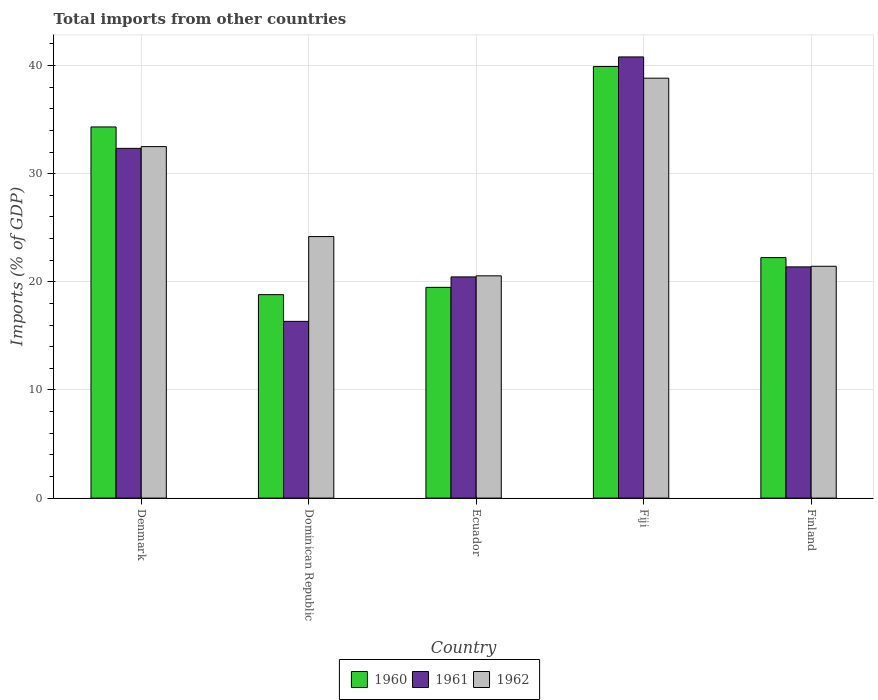How many groups of bars are there?
Your answer should be compact. 5. Are the number of bars per tick equal to the number of legend labels?
Your answer should be very brief. Yes. What is the label of the 2nd group of bars from the left?
Give a very brief answer. Dominican Republic. In how many cases, is the number of bars for a given country not equal to the number of legend labels?
Provide a short and direct response. 0. What is the total imports in 1961 in Denmark?
Provide a short and direct response. 32.34. Across all countries, what is the maximum total imports in 1960?
Your response must be concise. 39.91. Across all countries, what is the minimum total imports in 1960?
Offer a very short reply. 18.81. In which country was the total imports in 1962 maximum?
Your response must be concise. Fiji. In which country was the total imports in 1962 minimum?
Your response must be concise. Ecuador. What is the total total imports in 1962 in the graph?
Offer a terse response. 137.51. What is the difference between the total imports in 1962 in Fiji and that in Finland?
Your answer should be compact. 17.39. What is the difference between the total imports in 1961 in Finland and the total imports in 1960 in Fiji?
Offer a very short reply. -18.53. What is the average total imports in 1961 per country?
Provide a succinct answer. 26.26. What is the difference between the total imports of/in 1962 and total imports of/in 1961 in Dominican Republic?
Offer a very short reply. 7.84. What is the ratio of the total imports in 1961 in Dominican Republic to that in Fiji?
Provide a short and direct response. 0.4. Is the total imports in 1960 in Denmark less than that in Fiji?
Provide a short and direct response. Yes. Is the difference between the total imports in 1962 in Denmark and Ecuador greater than the difference between the total imports in 1961 in Denmark and Ecuador?
Offer a terse response. Yes. What is the difference between the highest and the second highest total imports in 1960?
Keep it short and to the point. 12.08. What is the difference between the highest and the lowest total imports in 1960?
Offer a very short reply. 21.1. Is the sum of the total imports in 1962 in Ecuador and Fiji greater than the maximum total imports in 1961 across all countries?
Make the answer very short. Yes. What does the 1st bar from the left in Finland represents?
Keep it short and to the point. 1960. What does the 3rd bar from the right in Denmark represents?
Provide a succinct answer. 1960. Is it the case that in every country, the sum of the total imports in 1961 and total imports in 1962 is greater than the total imports in 1960?
Give a very brief answer. Yes. How many bars are there?
Your answer should be compact. 15. What is the difference between two consecutive major ticks on the Y-axis?
Ensure brevity in your answer.  10. Does the graph contain any zero values?
Make the answer very short. No. Where does the legend appear in the graph?
Keep it short and to the point. Bottom center. What is the title of the graph?
Make the answer very short. Total imports from other countries. Does "1986" appear as one of the legend labels in the graph?
Provide a succinct answer. No. What is the label or title of the Y-axis?
Make the answer very short. Imports (% of GDP). What is the Imports (% of GDP) of 1960 in Denmark?
Your answer should be very brief. 34.32. What is the Imports (% of GDP) of 1961 in Denmark?
Ensure brevity in your answer.  32.34. What is the Imports (% of GDP) of 1962 in Denmark?
Your response must be concise. 32.5. What is the Imports (% of GDP) in 1960 in Dominican Republic?
Offer a terse response. 18.81. What is the Imports (% of GDP) in 1961 in Dominican Republic?
Ensure brevity in your answer.  16.34. What is the Imports (% of GDP) of 1962 in Dominican Republic?
Ensure brevity in your answer.  24.18. What is the Imports (% of GDP) of 1960 in Ecuador?
Offer a terse response. 19.49. What is the Imports (% of GDP) of 1961 in Ecuador?
Provide a succinct answer. 20.45. What is the Imports (% of GDP) of 1962 in Ecuador?
Offer a terse response. 20.55. What is the Imports (% of GDP) in 1960 in Fiji?
Keep it short and to the point. 39.91. What is the Imports (% of GDP) of 1961 in Fiji?
Make the answer very short. 40.8. What is the Imports (% of GDP) of 1962 in Fiji?
Provide a succinct answer. 38.83. What is the Imports (% of GDP) in 1960 in Finland?
Offer a terse response. 22.24. What is the Imports (% of GDP) of 1961 in Finland?
Provide a short and direct response. 21.38. What is the Imports (% of GDP) of 1962 in Finland?
Give a very brief answer. 21.44. Across all countries, what is the maximum Imports (% of GDP) of 1960?
Offer a terse response. 39.91. Across all countries, what is the maximum Imports (% of GDP) of 1961?
Your response must be concise. 40.8. Across all countries, what is the maximum Imports (% of GDP) in 1962?
Offer a terse response. 38.83. Across all countries, what is the minimum Imports (% of GDP) in 1960?
Keep it short and to the point. 18.81. Across all countries, what is the minimum Imports (% of GDP) of 1961?
Offer a terse response. 16.34. Across all countries, what is the minimum Imports (% of GDP) of 1962?
Offer a terse response. 20.55. What is the total Imports (% of GDP) of 1960 in the graph?
Offer a very short reply. 134.77. What is the total Imports (% of GDP) in 1961 in the graph?
Keep it short and to the point. 131.32. What is the total Imports (% of GDP) in 1962 in the graph?
Provide a short and direct response. 137.51. What is the difference between the Imports (% of GDP) in 1960 in Denmark and that in Dominican Republic?
Your response must be concise. 15.51. What is the difference between the Imports (% of GDP) of 1961 in Denmark and that in Dominican Republic?
Your answer should be compact. 16. What is the difference between the Imports (% of GDP) in 1962 in Denmark and that in Dominican Republic?
Offer a terse response. 8.32. What is the difference between the Imports (% of GDP) in 1960 in Denmark and that in Ecuador?
Keep it short and to the point. 14.83. What is the difference between the Imports (% of GDP) of 1961 in Denmark and that in Ecuador?
Give a very brief answer. 11.89. What is the difference between the Imports (% of GDP) of 1962 in Denmark and that in Ecuador?
Provide a succinct answer. 11.95. What is the difference between the Imports (% of GDP) in 1960 in Denmark and that in Fiji?
Keep it short and to the point. -5.59. What is the difference between the Imports (% of GDP) of 1961 in Denmark and that in Fiji?
Provide a short and direct response. -8.45. What is the difference between the Imports (% of GDP) in 1962 in Denmark and that in Fiji?
Give a very brief answer. -6.33. What is the difference between the Imports (% of GDP) in 1960 in Denmark and that in Finland?
Give a very brief answer. 12.08. What is the difference between the Imports (% of GDP) of 1961 in Denmark and that in Finland?
Your response must be concise. 10.96. What is the difference between the Imports (% of GDP) of 1962 in Denmark and that in Finland?
Offer a very short reply. 11.07. What is the difference between the Imports (% of GDP) of 1960 in Dominican Republic and that in Ecuador?
Your answer should be very brief. -0.68. What is the difference between the Imports (% of GDP) of 1961 in Dominican Republic and that in Ecuador?
Make the answer very short. -4.11. What is the difference between the Imports (% of GDP) in 1962 in Dominican Republic and that in Ecuador?
Provide a short and direct response. 3.63. What is the difference between the Imports (% of GDP) of 1960 in Dominican Republic and that in Fiji?
Give a very brief answer. -21.1. What is the difference between the Imports (% of GDP) in 1961 in Dominican Republic and that in Fiji?
Give a very brief answer. -24.45. What is the difference between the Imports (% of GDP) of 1962 in Dominican Republic and that in Fiji?
Your response must be concise. -14.65. What is the difference between the Imports (% of GDP) in 1960 in Dominican Republic and that in Finland?
Your answer should be very brief. -3.43. What is the difference between the Imports (% of GDP) in 1961 in Dominican Republic and that in Finland?
Provide a short and direct response. -5.04. What is the difference between the Imports (% of GDP) in 1962 in Dominican Republic and that in Finland?
Provide a succinct answer. 2.75. What is the difference between the Imports (% of GDP) in 1960 in Ecuador and that in Fiji?
Ensure brevity in your answer.  -20.42. What is the difference between the Imports (% of GDP) of 1961 in Ecuador and that in Fiji?
Your response must be concise. -20.34. What is the difference between the Imports (% of GDP) of 1962 in Ecuador and that in Fiji?
Offer a terse response. -18.28. What is the difference between the Imports (% of GDP) of 1960 in Ecuador and that in Finland?
Offer a very short reply. -2.75. What is the difference between the Imports (% of GDP) of 1961 in Ecuador and that in Finland?
Ensure brevity in your answer.  -0.93. What is the difference between the Imports (% of GDP) of 1962 in Ecuador and that in Finland?
Keep it short and to the point. -0.88. What is the difference between the Imports (% of GDP) of 1960 in Fiji and that in Finland?
Provide a short and direct response. 17.67. What is the difference between the Imports (% of GDP) of 1961 in Fiji and that in Finland?
Ensure brevity in your answer.  19.41. What is the difference between the Imports (% of GDP) in 1962 in Fiji and that in Finland?
Give a very brief answer. 17.39. What is the difference between the Imports (% of GDP) in 1960 in Denmark and the Imports (% of GDP) in 1961 in Dominican Republic?
Offer a very short reply. 17.98. What is the difference between the Imports (% of GDP) in 1960 in Denmark and the Imports (% of GDP) in 1962 in Dominican Republic?
Keep it short and to the point. 10.14. What is the difference between the Imports (% of GDP) in 1961 in Denmark and the Imports (% of GDP) in 1962 in Dominican Republic?
Offer a terse response. 8.16. What is the difference between the Imports (% of GDP) of 1960 in Denmark and the Imports (% of GDP) of 1961 in Ecuador?
Keep it short and to the point. 13.87. What is the difference between the Imports (% of GDP) of 1960 in Denmark and the Imports (% of GDP) of 1962 in Ecuador?
Offer a terse response. 13.77. What is the difference between the Imports (% of GDP) of 1961 in Denmark and the Imports (% of GDP) of 1962 in Ecuador?
Provide a short and direct response. 11.79. What is the difference between the Imports (% of GDP) in 1960 in Denmark and the Imports (% of GDP) in 1961 in Fiji?
Offer a very short reply. -6.47. What is the difference between the Imports (% of GDP) of 1960 in Denmark and the Imports (% of GDP) of 1962 in Fiji?
Ensure brevity in your answer.  -4.51. What is the difference between the Imports (% of GDP) in 1961 in Denmark and the Imports (% of GDP) in 1962 in Fiji?
Your response must be concise. -6.49. What is the difference between the Imports (% of GDP) of 1960 in Denmark and the Imports (% of GDP) of 1961 in Finland?
Provide a succinct answer. 12.94. What is the difference between the Imports (% of GDP) in 1960 in Denmark and the Imports (% of GDP) in 1962 in Finland?
Your response must be concise. 12.88. What is the difference between the Imports (% of GDP) in 1961 in Denmark and the Imports (% of GDP) in 1962 in Finland?
Your answer should be compact. 10.9. What is the difference between the Imports (% of GDP) of 1960 in Dominican Republic and the Imports (% of GDP) of 1961 in Ecuador?
Offer a very short reply. -1.64. What is the difference between the Imports (% of GDP) of 1960 in Dominican Republic and the Imports (% of GDP) of 1962 in Ecuador?
Give a very brief answer. -1.74. What is the difference between the Imports (% of GDP) in 1961 in Dominican Republic and the Imports (% of GDP) in 1962 in Ecuador?
Your response must be concise. -4.21. What is the difference between the Imports (% of GDP) of 1960 in Dominican Republic and the Imports (% of GDP) of 1961 in Fiji?
Offer a very short reply. -21.98. What is the difference between the Imports (% of GDP) in 1960 in Dominican Republic and the Imports (% of GDP) in 1962 in Fiji?
Ensure brevity in your answer.  -20.02. What is the difference between the Imports (% of GDP) in 1961 in Dominican Republic and the Imports (% of GDP) in 1962 in Fiji?
Offer a very short reply. -22.49. What is the difference between the Imports (% of GDP) in 1960 in Dominican Republic and the Imports (% of GDP) in 1961 in Finland?
Ensure brevity in your answer.  -2.57. What is the difference between the Imports (% of GDP) of 1960 in Dominican Republic and the Imports (% of GDP) of 1962 in Finland?
Make the answer very short. -2.62. What is the difference between the Imports (% of GDP) of 1961 in Dominican Republic and the Imports (% of GDP) of 1962 in Finland?
Your answer should be compact. -5.09. What is the difference between the Imports (% of GDP) in 1960 in Ecuador and the Imports (% of GDP) in 1961 in Fiji?
Your response must be concise. -21.31. What is the difference between the Imports (% of GDP) in 1960 in Ecuador and the Imports (% of GDP) in 1962 in Fiji?
Give a very brief answer. -19.34. What is the difference between the Imports (% of GDP) in 1961 in Ecuador and the Imports (% of GDP) in 1962 in Fiji?
Keep it short and to the point. -18.38. What is the difference between the Imports (% of GDP) of 1960 in Ecuador and the Imports (% of GDP) of 1961 in Finland?
Your answer should be compact. -1.89. What is the difference between the Imports (% of GDP) of 1960 in Ecuador and the Imports (% of GDP) of 1962 in Finland?
Offer a terse response. -1.95. What is the difference between the Imports (% of GDP) of 1961 in Ecuador and the Imports (% of GDP) of 1962 in Finland?
Keep it short and to the point. -0.98. What is the difference between the Imports (% of GDP) of 1960 in Fiji and the Imports (% of GDP) of 1961 in Finland?
Make the answer very short. 18.53. What is the difference between the Imports (% of GDP) of 1960 in Fiji and the Imports (% of GDP) of 1962 in Finland?
Provide a succinct answer. 18.47. What is the difference between the Imports (% of GDP) in 1961 in Fiji and the Imports (% of GDP) in 1962 in Finland?
Provide a succinct answer. 19.36. What is the average Imports (% of GDP) of 1960 per country?
Offer a terse response. 26.95. What is the average Imports (% of GDP) of 1961 per country?
Provide a succinct answer. 26.26. What is the average Imports (% of GDP) of 1962 per country?
Give a very brief answer. 27.5. What is the difference between the Imports (% of GDP) of 1960 and Imports (% of GDP) of 1961 in Denmark?
Provide a succinct answer. 1.98. What is the difference between the Imports (% of GDP) of 1960 and Imports (% of GDP) of 1962 in Denmark?
Keep it short and to the point. 1.82. What is the difference between the Imports (% of GDP) in 1961 and Imports (% of GDP) in 1962 in Denmark?
Give a very brief answer. -0.16. What is the difference between the Imports (% of GDP) of 1960 and Imports (% of GDP) of 1961 in Dominican Republic?
Your answer should be compact. 2.47. What is the difference between the Imports (% of GDP) in 1960 and Imports (% of GDP) in 1962 in Dominican Republic?
Your answer should be compact. -5.37. What is the difference between the Imports (% of GDP) of 1961 and Imports (% of GDP) of 1962 in Dominican Republic?
Keep it short and to the point. -7.84. What is the difference between the Imports (% of GDP) in 1960 and Imports (% of GDP) in 1961 in Ecuador?
Make the answer very short. -0.97. What is the difference between the Imports (% of GDP) of 1960 and Imports (% of GDP) of 1962 in Ecuador?
Keep it short and to the point. -1.07. What is the difference between the Imports (% of GDP) in 1961 and Imports (% of GDP) in 1962 in Ecuador?
Give a very brief answer. -0.1. What is the difference between the Imports (% of GDP) of 1960 and Imports (% of GDP) of 1961 in Fiji?
Your answer should be compact. -0.89. What is the difference between the Imports (% of GDP) in 1960 and Imports (% of GDP) in 1962 in Fiji?
Give a very brief answer. 1.08. What is the difference between the Imports (% of GDP) in 1961 and Imports (% of GDP) in 1962 in Fiji?
Provide a succinct answer. 1.96. What is the difference between the Imports (% of GDP) in 1960 and Imports (% of GDP) in 1961 in Finland?
Offer a very short reply. 0.86. What is the difference between the Imports (% of GDP) of 1960 and Imports (% of GDP) of 1962 in Finland?
Keep it short and to the point. 0.8. What is the difference between the Imports (% of GDP) of 1961 and Imports (% of GDP) of 1962 in Finland?
Provide a succinct answer. -0.06. What is the ratio of the Imports (% of GDP) in 1960 in Denmark to that in Dominican Republic?
Your answer should be compact. 1.82. What is the ratio of the Imports (% of GDP) of 1961 in Denmark to that in Dominican Republic?
Your response must be concise. 1.98. What is the ratio of the Imports (% of GDP) of 1962 in Denmark to that in Dominican Republic?
Offer a terse response. 1.34. What is the ratio of the Imports (% of GDP) of 1960 in Denmark to that in Ecuador?
Give a very brief answer. 1.76. What is the ratio of the Imports (% of GDP) in 1961 in Denmark to that in Ecuador?
Ensure brevity in your answer.  1.58. What is the ratio of the Imports (% of GDP) in 1962 in Denmark to that in Ecuador?
Offer a very short reply. 1.58. What is the ratio of the Imports (% of GDP) of 1960 in Denmark to that in Fiji?
Ensure brevity in your answer.  0.86. What is the ratio of the Imports (% of GDP) in 1961 in Denmark to that in Fiji?
Keep it short and to the point. 0.79. What is the ratio of the Imports (% of GDP) of 1962 in Denmark to that in Fiji?
Make the answer very short. 0.84. What is the ratio of the Imports (% of GDP) of 1960 in Denmark to that in Finland?
Give a very brief answer. 1.54. What is the ratio of the Imports (% of GDP) of 1961 in Denmark to that in Finland?
Your answer should be compact. 1.51. What is the ratio of the Imports (% of GDP) in 1962 in Denmark to that in Finland?
Your answer should be compact. 1.52. What is the ratio of the Imports (% of GDP) of 1960 in Dominican Republic to that in Ecuador?
Offer a terse response. 0.97. What is the ratio of the Imports (% of GDP) in 1961 in Dominican Republic to that in Ecuador?
Offer a terse response. 0.8. What is the ratio of the Imports (% of GDP) in 1962 in Dominican Republic to that in Ecuador?
Make the answer very short. 1.18. What is the ratio of the Imports (% of GDP) in 1960 in Dominican Republic to that in Fiji?
Your response must be concise. 0.47. What is the ratio of the Imports (% of GDP) in 1961 in Dominican Republic to that in Fiji?
Offer a very short reply. 0.4. What is the ratio of the Imports (% of GDP) in 1962 in Dominican Republic to that in Fiji?
Offer a very short reply. 0.62. What is the ratio of the Imports (% of GDP) of 1960 in Dominican Republic to that in Finland?
Provide a succinct answer. 0.85. What is the ratio of the Imports (% of GDP) of 1961 in Dominican Republic to that in Finland?
Your response must be concise. 0.76. What is the ratio of the Imports (% of GDP) in 1962 in Dominican Republic to that in Finland?
Provide a short and direct response. 1.13. What is the ratio of the Imports (% of GDP) of 1960 in Ecuador to that in Fiji?
Keep it short and to the point. 0.49. What is the ratio of the Imports (% of GDP) of 1961 in Ecuador to that in Fiji?
Provide a short and direct response. 0.5. What is the ratio of the Imports (% of GDP) of 1962 in Ecuador to that in Fiji?
Your answer should be compact. 0.53. What is the ratio of the Imports (% of GDP) in 1960 in Ecuador to that in Finland?
Your answer should be compact. 0.88. What is the ratio of the Imports (% of GDP) of 1961 in Ecuador to that in Finland?
Keep it short and to the point. 0.96. What is the ratio of the Imports (% of GDP) in 1962 in Ecuador to that in Finland?
Keep it short and to the point. 0.96. What is the ratio of the Imports (% of GDP) in 1960 in Fiji to that in Finland?
Provide a short and direct response. 1.79. What is the ratio of the Imports (% of GDP) in 1961 in Fiji to that in Finland?
Ensure brevity in your answer.  1.91. What is the ratio of the Imports (% of GDP) in 1962 in Fiji to that in Finland?
Give a very brief answer. 1.81. What is the difference between the highest and the second highest Imports (% of GDP) in 1960?
Ensure brevity in your answer.  5.59. What is the difference between the highest and the second highest Imports (% of GDP) of 1961?
Make the answer very short. 8.45. What is the difference between the highest and the second highest Imports (% of GDP) of 1962?
Make the answer very short. 6.33. What is the difference between the highest and the lowest Imports (% of GDP) of 1960?
Your answer should be compact. 21.1. What is the difference between the highest and the lowest Imports (% of GDP) in 1961?
Keep it short and to the point. 24.45. What is the difference between the highest and the lowest Imports (% of GDP) in 1962?
Your answer should be compact. 18.28. 